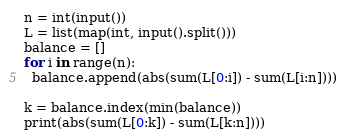<code> <loc_0><loc_0><loc_500><loc_500><_Python_>n = int(input())
L = list(map(int, input().split()))
balance = []
for i in range(n):
  balance.append(abs(sum(L[0:i]) - sum(L[i:n])))

k = balance.index(min(balance))
print(abs(sum(L[0:k]) - sum(L[k:n])))</code> 